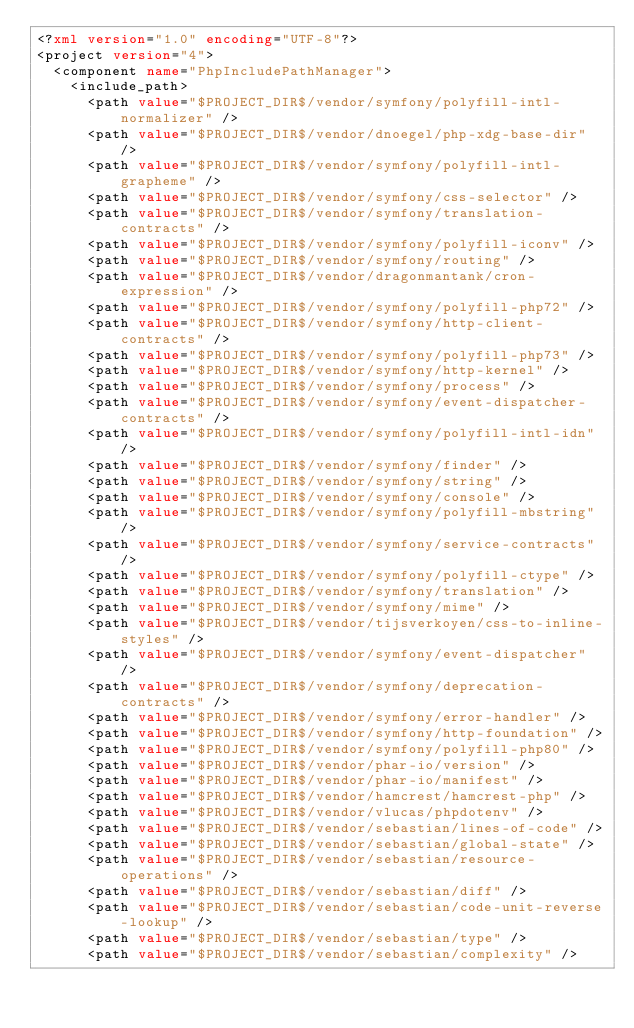Convert code to text. <code><loc_0><loc_0><loc_500><loc_500><_XML_><?xml version="1.0" encoding="UTF-8"?>
<project version="4">
  <component name="PhpIncludePathManager">
    <include_path>
      <path value="$PROJECT_DIR$/vendor/symfony/polyfill-intl-normalizer" />
      <path value="$PROJECT_DIR$/vendor/dnoegel/php-xdg-base-dir" />
      <path value="$PROJECT_DIR$/vendor/symfony/polyfill-intl-grapheme" />
      <path value="$PROJECT_DIR$/vendor/symfony/css-selector" />
      <path value="$PROJECT_DIR$/vendor/symfony/translation-contracts" />
      <path value="$PROJECT_DIR$/vendor/symfony/polyfill-iconv" />
      <path value="$PROJECT_DIR$/vendor/symfony/routing" />
      <path value="$PROJECT_DIR$/vendor/dragonmantank/cron-expression" />
      <path value="$PROJECT_DIR$/vendor/symfony/polyfill-php72" />
      <path value="$PROJECT_DIR$/vendor/symfony/http-client-contracts" />
      <path value="$PROJECT_DIR$/vendor/symfony/polyfill-php73" />
      <path value="$PROJECT_DIR$/vendor/symfony/http-kernel" />
      <path value="$PROJECT_DIR$/vendor/symfony/process" />
      <path value="$PROJECT_DIR$/vendor/symfony/event-dispatcher-contracts" />
      <path value="$PROJECT_DIR$/vendor/symfony/polyfill-intl-idn" />
      <path value="$PROJECT_DIR$/vendor/symfony/finder" />
      <path value="$PROJECT_DIR$/vendor/symfony/string" />
      <path value="$PROJECT_DIR$/vendor/symfony/console" />
      <path value="$PROJECT_DIR$/vendor/symfony/polyfill-mbstring" />
      <path value="$PROJECT_DIR$/vendor/symfony/service-contracts" />
      <path value="$PROJECT_DIR$/vendor/symfony/polyfill-ctype" />
      <path value="$PROJECT_DIR$/vendor/symfony/translation" />
      <path value="$PROJECT_DIR$/vendor/symfony/mime" />
      <path value="$PROJECT_DIR$/vendor/tijsverkoyen/css-to-inline-styles" />
      <path value="$PROJECT_DIR$/vendor/symfony/event-dispatcher" />
      <path value="$PROJECT_DIR$/vendor/symfony/deprecation-contracts" />
      <path value="$PROJECT_DIR$/vendor/symfony/error-handler" />
      <path value="$PROJECT_DIR$/vendor/symfony/http-foundation" />
      <path value="$PROJECT_DIR$/vendor/symfony/polyfill-php80" />
      <path value="$PROJECT_DIR$/vendor/phar-io/version" />
      <path value="$PROJECT_DIR$/vendor/phar-io/manifest" />
      <path value="$PROJECT_DIR$/vendor/hamcrest/hamcrest-php" />
      <path value="$PROJECT_DIR$/vendor/vlucas/phpdotenv" />
      <path value="$PROJECT_DIR$/vendor/sebastian/lines-of-code" />
      <path value="$PROJECT_DIR$/vendor/sebastian/global-state" />
      <path value="$PROJECT_DIR$/vendor/sebastian/resource-operations" />
      <path value="$PROJECT_DIR$/vendor/sebastian/diff" />
      <path value="$PROJECT_DIR$/vendor/sebastian/code-unit-reverse-lookup" />
      <path value="$PROJECT_DIR$/vendor/sebastian/type" />
      <path value="$PROJECT_DIR$/vendor/sebastian/complexity" /></code> 